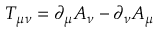Convert formula to latex. <formula><loc_0><loc_0><loc_500><loc_500>T _ { \mu \nu } = \partial _ { \mu } A _ { \nu } - \partial _ { \nu } A _ { \mu }</formula> 